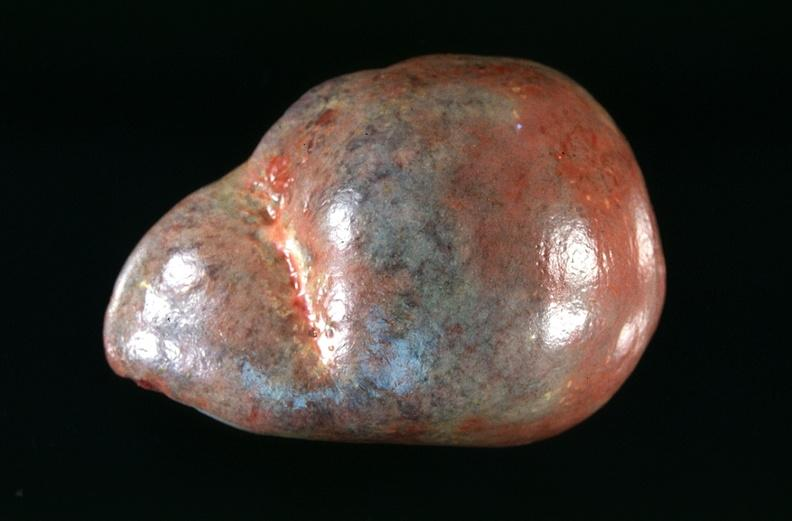does autopsy show spleen, congestion in a patient with disseminated intravascular coagulation and alpha-1 antitrypsin deficiency?
Answer the question using a single word or phrase. No 